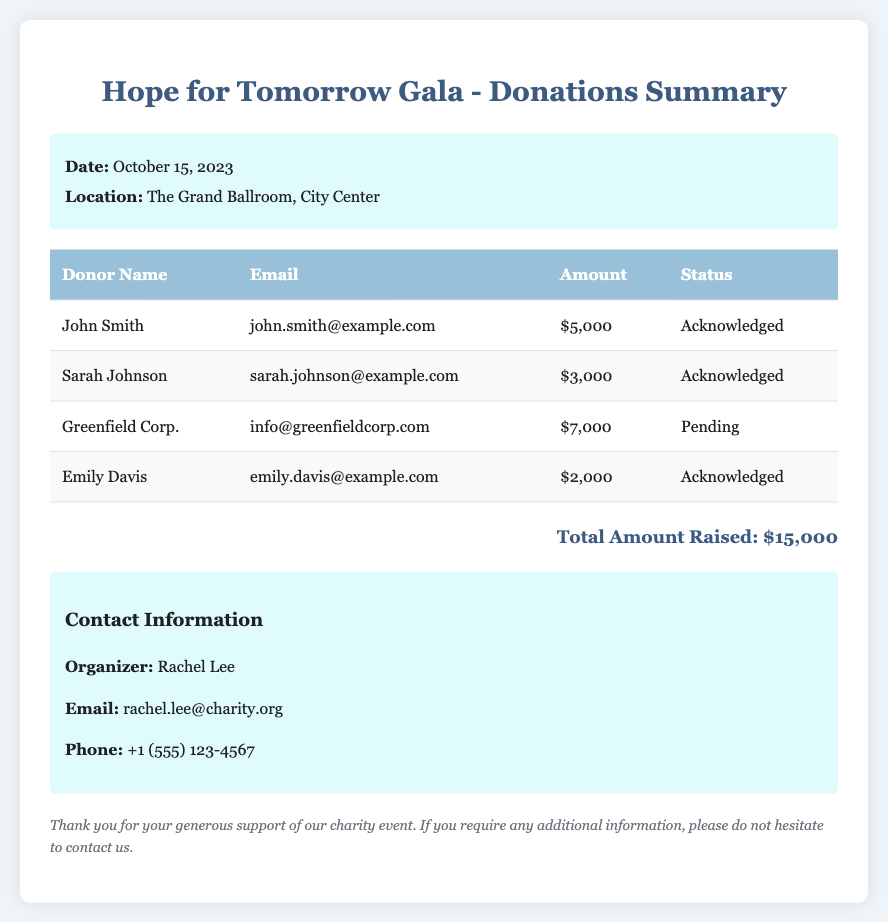What is the date of the event? The date of the event is mentioned in the event details section of the document.
Answer: October 15, 2023 Who is the event organizer? The organizer's name is listed in the contact information section of the document.
Answer: Rachel Lee What is the total amount raised? The total amount raised is located at the bottom of the document, summarizing the donations.
Answer: $15,000 Which donor has a pending acknowledgment status? The donor with a pending status can be found in the table under the status column.
Answer: Greenfield Corp How much did Sarah Johnson donate? The amount donated by Sarah Johnson can be found in the corresponding row in the table.
Answer: $3,000 What is the email address for John Smith? The email address is provided in the table next to John Smith’s name.
Answer: john.smith@example.com How many donors are acknowledged? This requires counting the rows with the status "Acknowledged" in the table.
Answer: 3 What is the contact phone number? The contact phone number is listed in the contact information section of the document.
Answer: +1 (555) 123-4567 What email address is provided for Greenfield Corp.? The email for Greenfield Corp. is included in the table in the contact detail column.
Answer: info@greenfieldcorp.com 